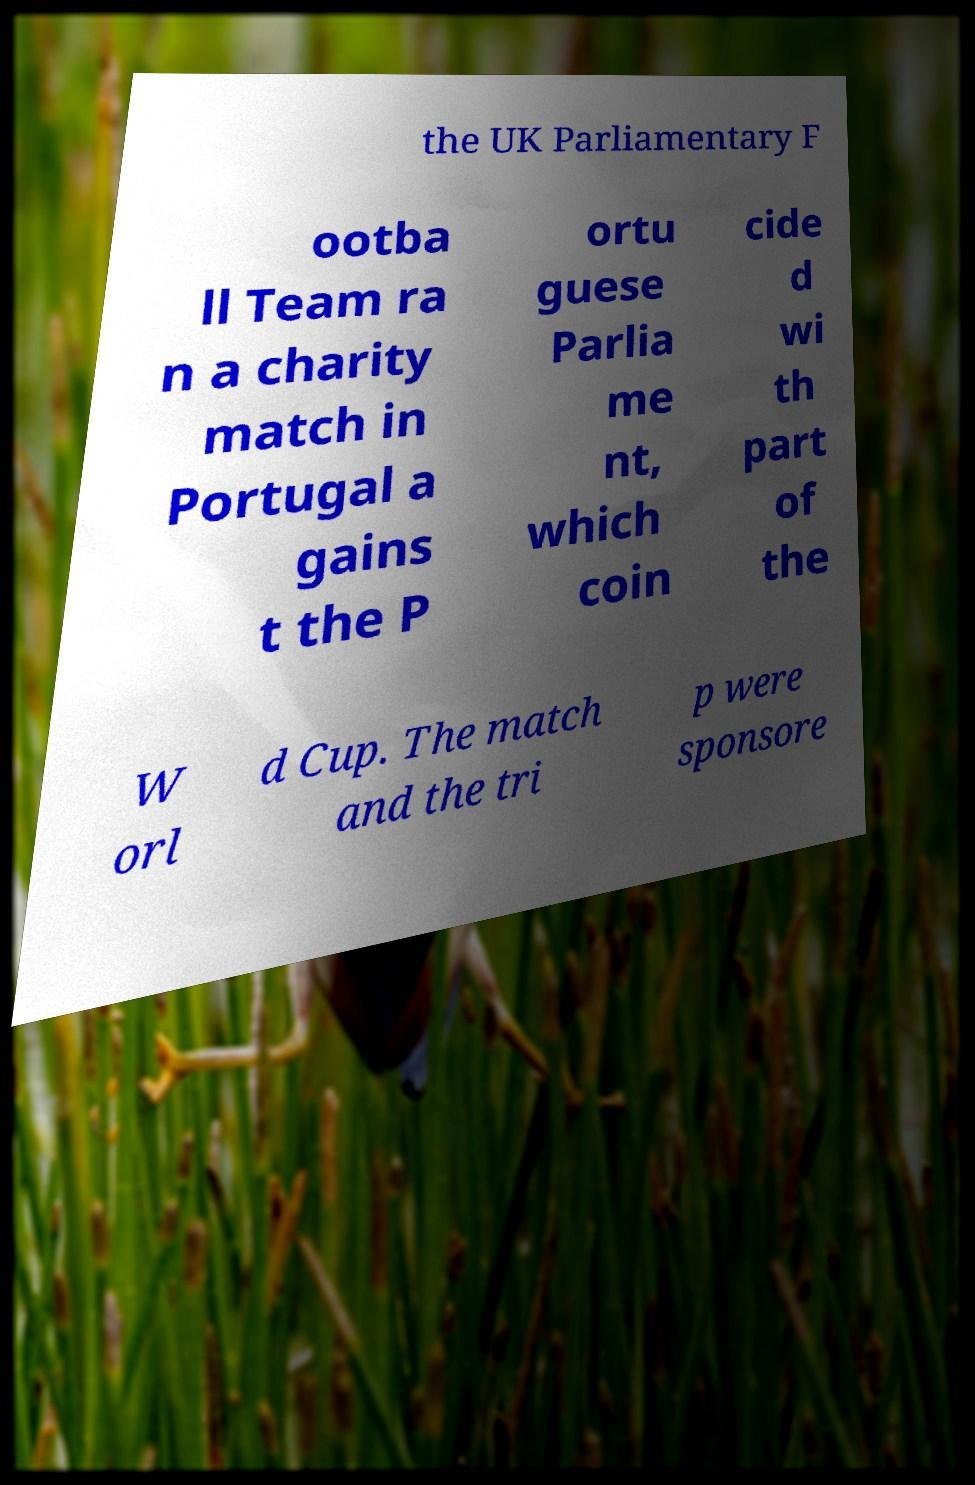For documentation purposes, I need the text within this image transcribed. Could you provide that? the UK Parliamentary F ootba ll Team ra n a charity match in Portugal a gains t the P ortu guese Parlia me nt, which coin cide d wi th part of the W orl d Cup. The match and the tri p were sponsore 